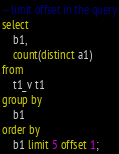<code> <loc_0><loc_0><loc_500><loc_500><_SQL_>-- limit offset in the query
select 
	b1,
	count(distinct a1) 
from 
	t1_v t1 
group by 
	b1 
order by 
	b1 limit 5 offset 1;
</code> 